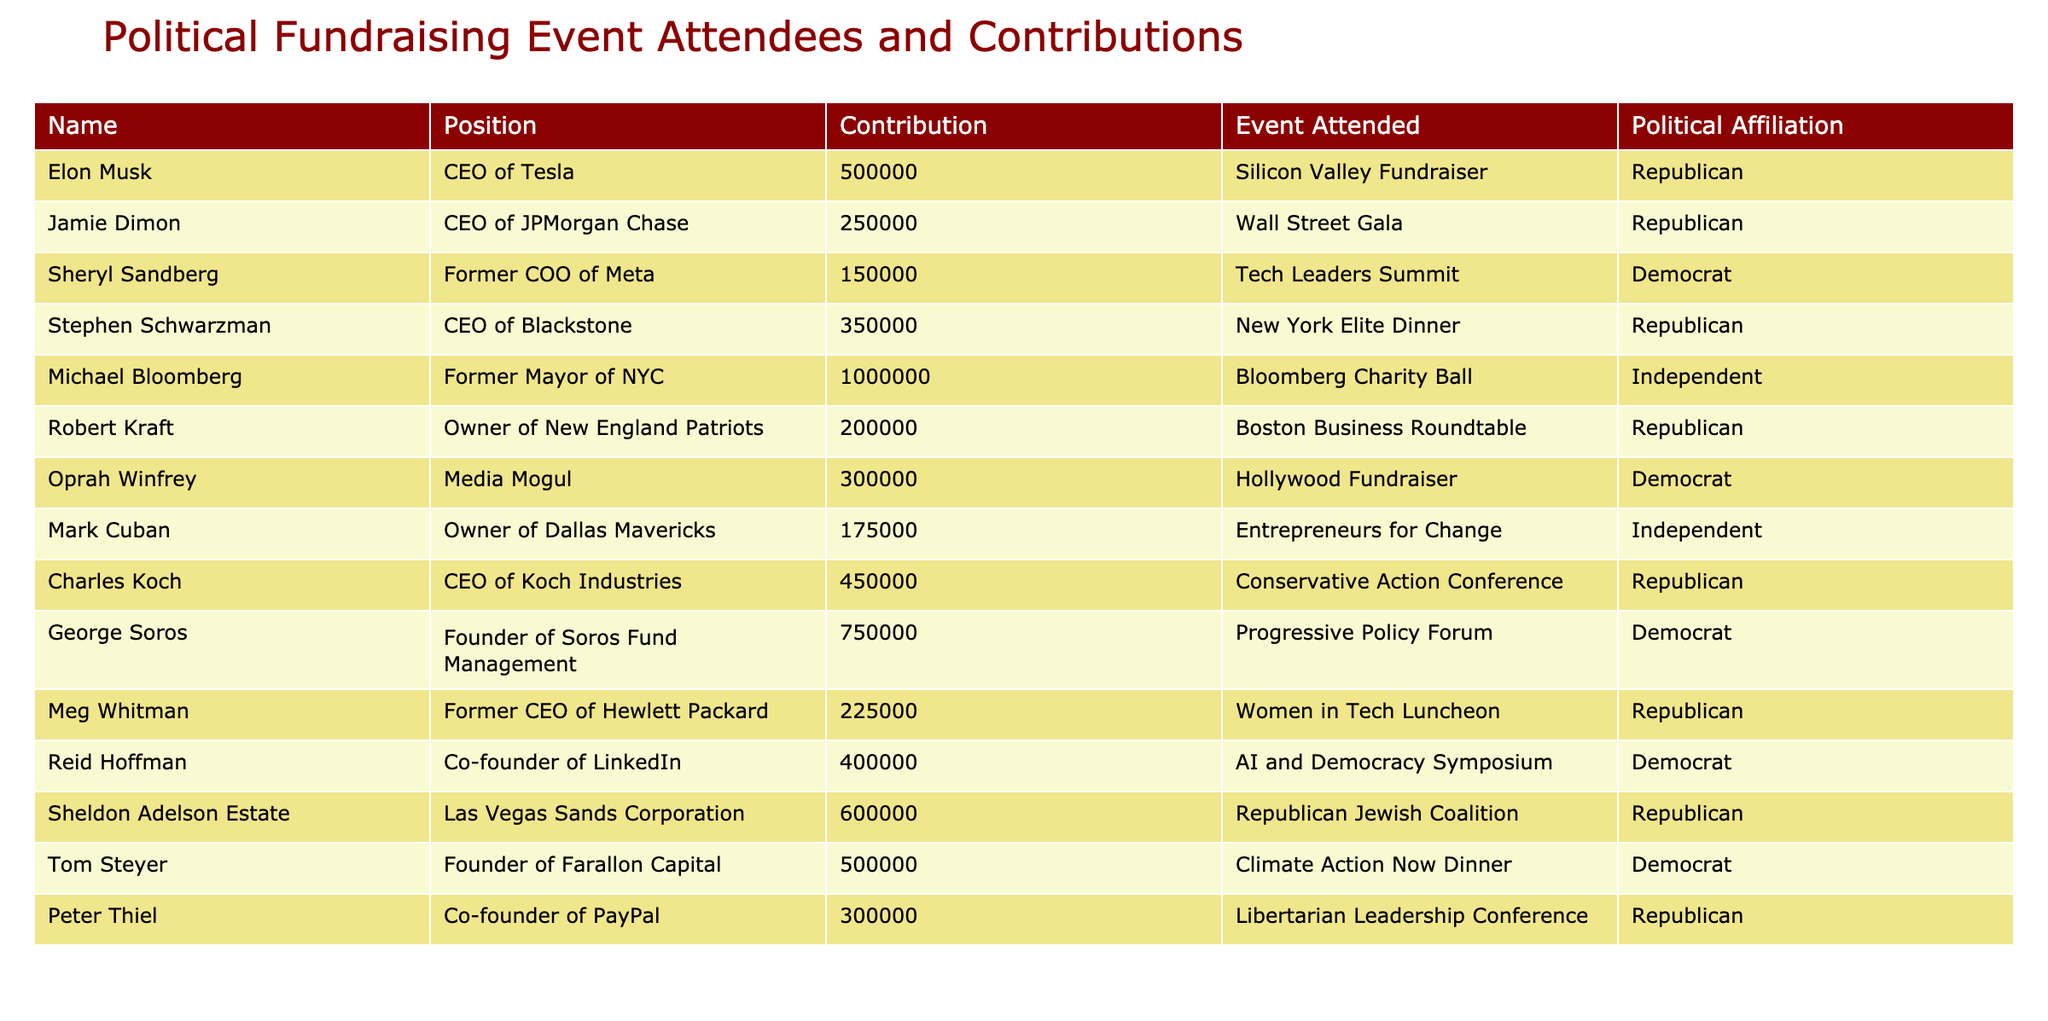What is the total contribution amount of all attendees? To find the total contribution, we sum the contributions of all attendees. The contributions are: 500000 + 250000 + 150000 + 350000 + 1000000 + 200000 + 300000 + 175000 + 450000 + 750000 + 225000 + 400000 + 600000 + 500000 + 300000 = 6330000.
Answer: 6330000 Which attendee contributed the most? By looking at the contributions listed in the table, the largest amount is 1000000 contributed by Michael Bloomberg.
Answer: Michael Bloomberg How many attendees identify as Republicans? We can count the number of attendees in the table with the political affiliation of Republican. The Republican attendees are: Elon Musk, Jamie Dimon, Stephen Schwarzman, Robert Kraft, Charles Koch, Meg Whitman, Sheldon Adelson Estate, Peter Thiel. This totals to 8 attendees.
Answer: 8 What is the average contribution amount of Democrat-affiliated attendees? To calculate the average contribution for Democrat attendees, we first sum their contributions: 150000 (Sheryl Sandberg) + 300000 (Oprah Winfrey) + 750000 (George Soros) + 400000 (Reid Hoffman) + 500000 (Tom Steyer) = 2300000. Then, since there are 5 Democrat attendees, we divide the total contribution by 5, resulting in an average of 2300000/5 = 460000.
Answer: 460000 Is it true that all attendees contributed over 100000? We examine the contribution amounts to see if any amounts are under 100000. The smallest contribution from the table is 100000 (Michael Bloomberg), which indicates that all contributions are indeed above or equal to 100000.
Answer: Yes Which position had the highest average contribution? To calculate the average contribution by position, we need to group the contributions by position and compute their averages: Total for CEOs (Elon Musk, Jamie Dimon, Stephen Schwarzman, Charles Koch, Meg Whitman, and Peter Thiel) = 500000 + 250000 + 350000 + 450000 + 225000 + 300000 = 2075000; there are 6 CEOs, so average = 2075000/6 = 345833.33. For Former COOs (Sheryl Sandberg) = 150000; for Media Moguls (Oprah Winfrey) = 300000; for Founders (Michael Bloomberg, George Soros, Tom Steyer) = 1000000 + 750000 + 500000 = 2300000, with 3 Founders = 766666.67. The highest average is for Founders.
Answer: Founders How many attendees contributed between 200000 and 500000? We scan the contributions and identify those in the range of 200000 to 500000. The contributions that fit this criterion are: 250000 (Jamie Dimon), 350000 (Stephen Schwarzman), 200000 (Robert Kraft), 225000 (Meg Whitman), and 300000 (Oprah Winfrey). That totals to 5 attendees.
Answer: 5 Which political affiliation has the highest total contribution? We need to sum the contributions by political affiliation. Republican contributions total 500000 + 250000 + 350000 + 200000 + 450000 + 225000 + 600000 + 300000 = 2875000. Democrat contributions total 150000 + 300000 + 750000 + 400000 + 500000 = 2300000. Independent contributions total 1000000 + 175000 = 1175000. The highest total belongs to Republicans with 2875000.
Answer: Republicans 